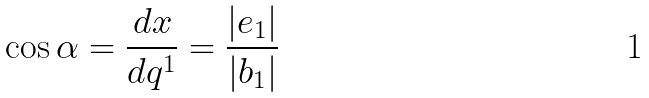Convert formula to latex. <formula><loc_0><loc_0><loc_500><loc_500>\cos \alpha = \frac { d x } { d q ^ { 1 } } = \frac { | e _ { 1 } | } { | b _ { 1 } | }</formula> 